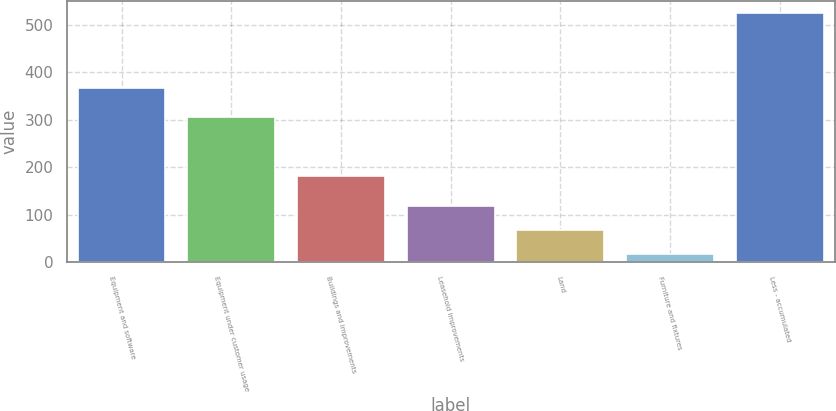Convert chart to OTSL. <chart><loc_0><loc_0><loc_500><loc_500><bar_chart><fcel>Equipment and software<fcel>Equipment under customer usage<fcel>Buildings and improvements<fcel>Leasehold improvements<fcel>Land<fcel>Furniture and fixtures<fcel>Less - accumulated<nl><fcel>365.9<fcel>305.7<fcel>182.1<fcel>118.74<fcel>68.02<fcel>17.3<fcel>524.5<nl></chart> 